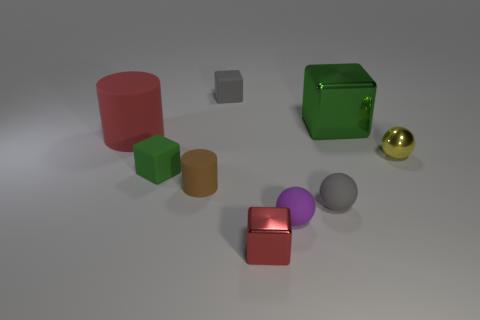Does the yellow object have the same size as the red cylinder?
Provide a succinct answer. No. How big is the red metal thing?
Provide a succinct answer. Small. What number of things are tiny metallic objects that are right of the big green thing or green matte blocks?
Keep it short and to the point. 2. What number of green things are to the right of the green cube that is right of the tiny gray rubber sphere?
Ensure brevity in your answer.  0. Are there fewer brown cylinders in front of the tiny red metal cube than small green things that are in front of the big cube?
Ensure brevity in your answer.  Yes. There is a metal thing in front of the tiny ball right of the tiny gray ball; what is its shape?
Offer a very short reply. Cube. How many other objects are there of the same material as the yellow object?
Your response must be concise. 2. Are there more small gray objects than purple matte balls?
Offer a very short reply. Yes. There is a shiny thing on the left side of the large thing that is right of the sphere left of the gray matte sphere; how big is it?
Provide a succinct answer. Small. Do the yellow thing and the green thing that is behind the yellow metal sphere have the same size?
Offer a terse response. No. 